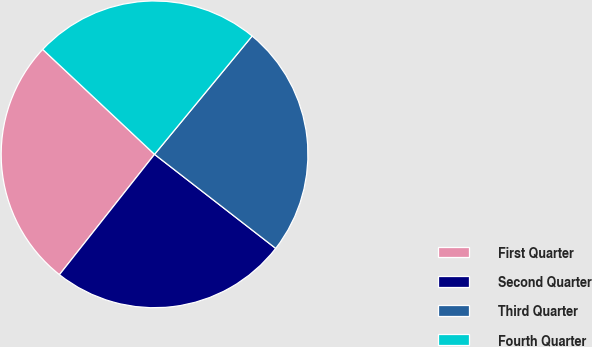Convert chart. <chart><loc_0><loc_0><loc_500><loc_500><pie_chart><fcel>First Quarter<fcel>Second Quarter<fcel>Third Quarter<fcel>Fourth Quarter<nl><fcel>26.35%<fcel>25.14%<fcel>24.53%<fcel>23.98%<nl></chart> 